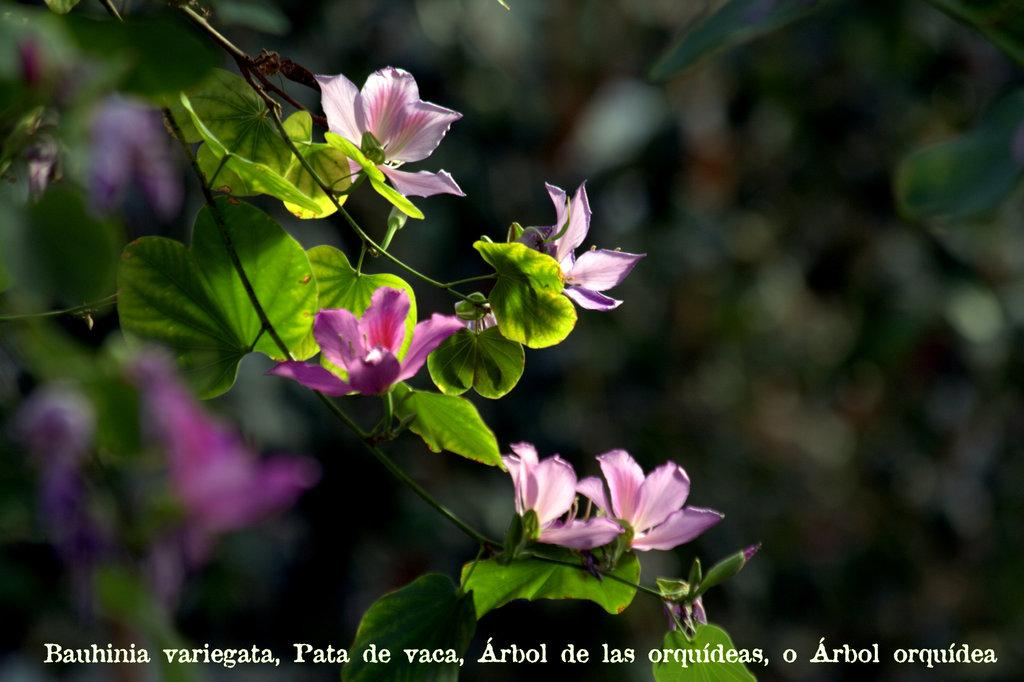What type of plants can be seen in the image? There are flowers and leaves in the image. What can be observed about the background of the image? The background of the image is blurred. Is there any additional information or marking present in the image? Yes, there is a watermark on the bottom part of the image. Can you describe the flight of the bird in the image? There is no bird present in the image, so it is not possible to describe its flight. 